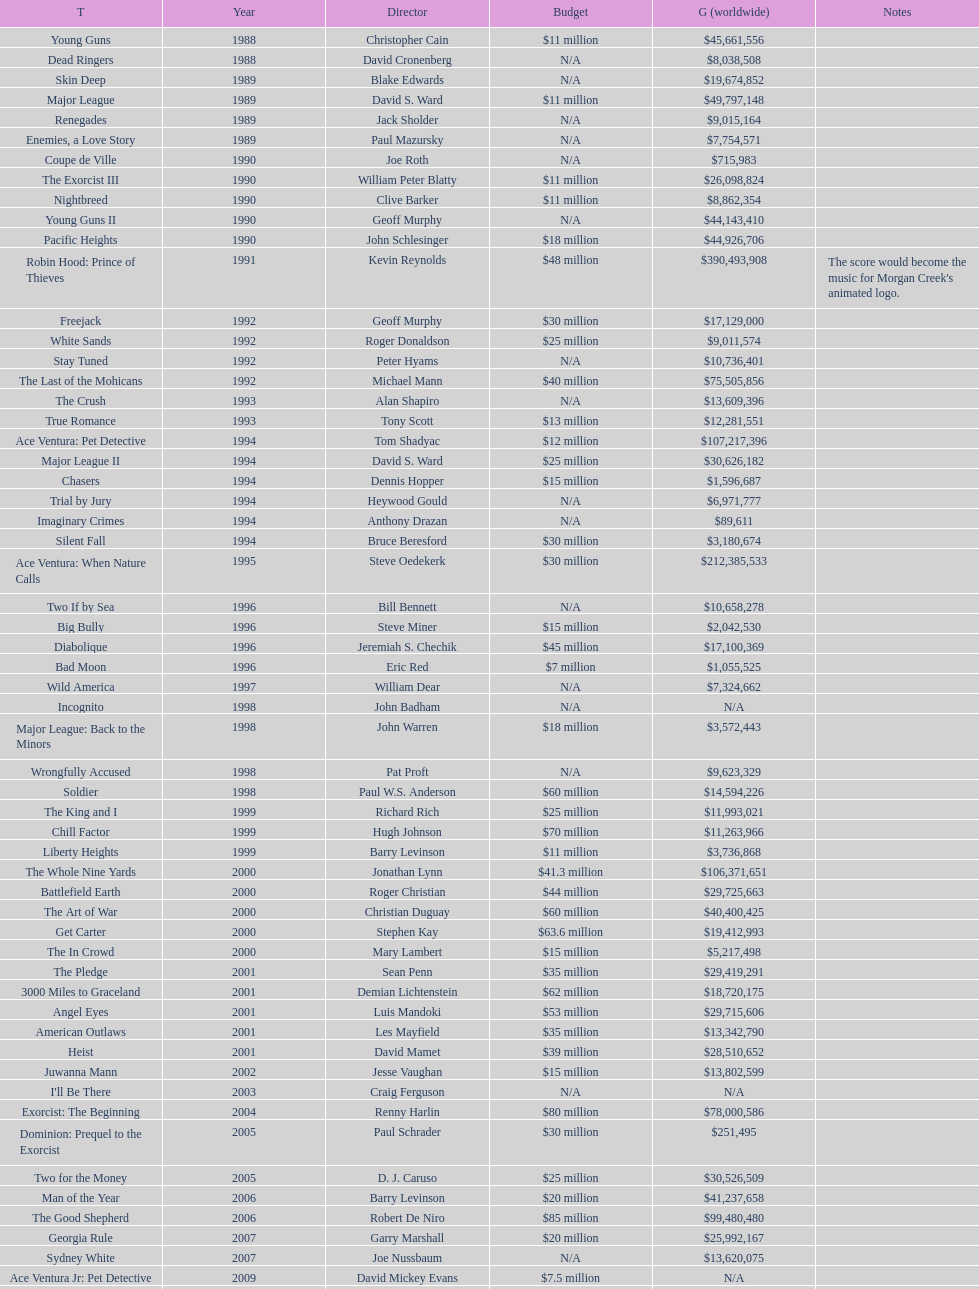After bad moon, what movie was premiered? Wild America. 